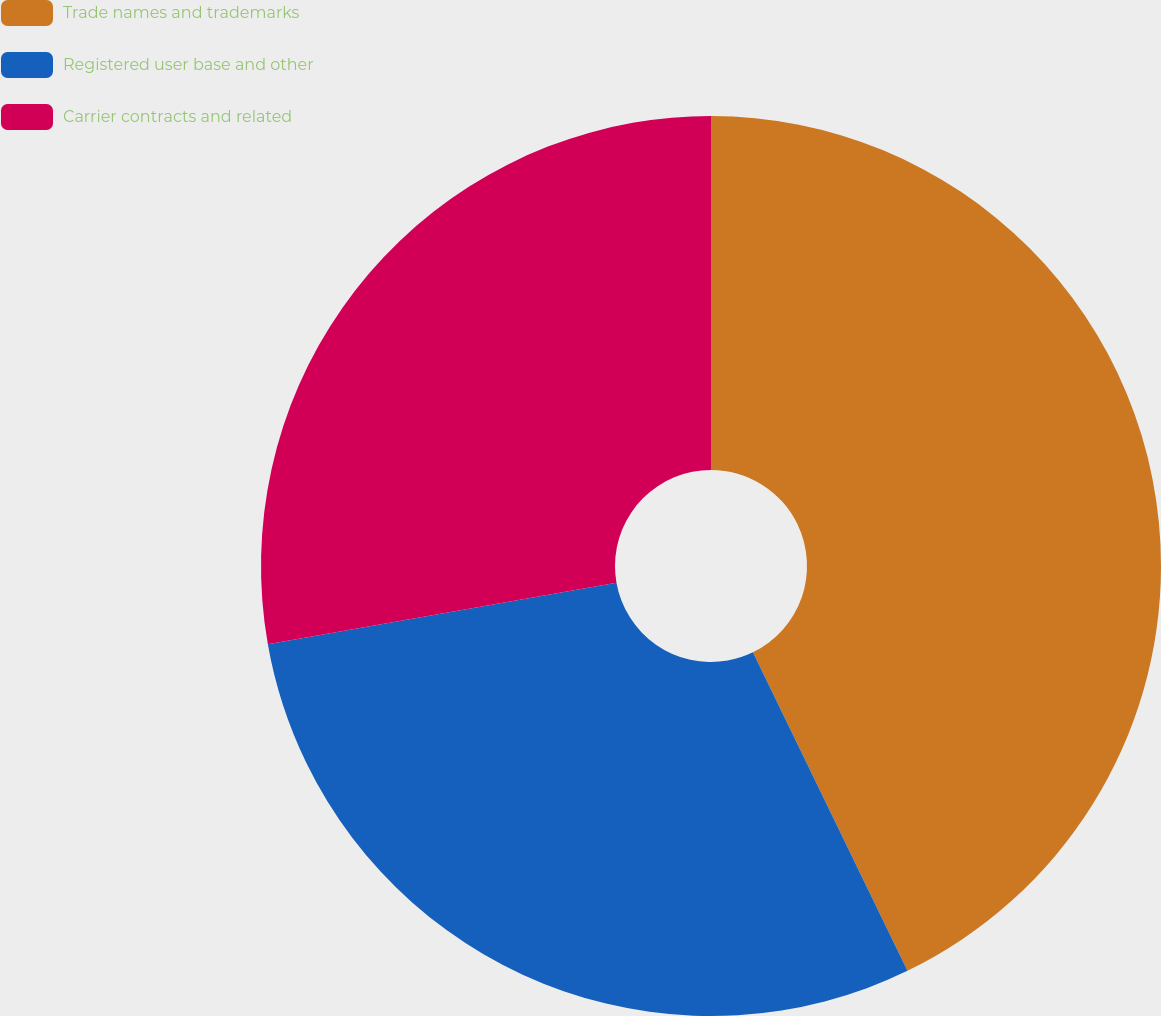<chart> <loc_0><loc_0><loc_500><loc_500><pie_chart><fcel>Trade names and trademarks<fcel>Registered user base and other<fcel>Carrier contracts and related<nl><fcel>42.81%<fcel>29.41%<fcel>27.78%<nl></chart> 